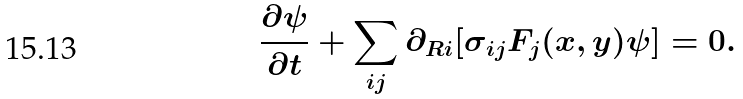Convert formula to latex. <formula><loc_0><loc_0><loc_500><loc_500>\frac { \partial \psi } { \partial { t } } + \sum _ { i j } \partial _ { R i } [ { \sigma } _ { i j } { F } _ { j } ( x , y ) \psi ] = 0 .</formula> 